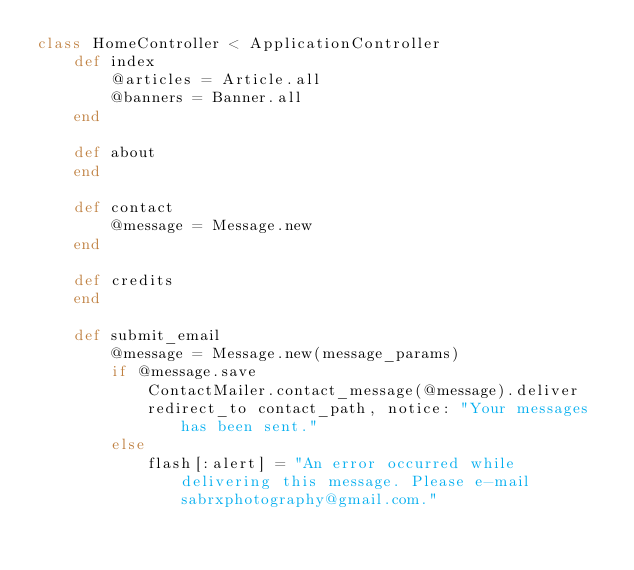Convert code to text. <code><loc_0><loc_0><loc_500><loc_500><_Ruby_>class HomeController < ApplicationController
	def index
		@articles = Article.all
		@banners = Banner.all
	end

	def about
	end

	def contact
		@message = Message.new
	end

	def credits
	end
	
	def submit_email
		@message = Message.new(message_params)
		if @message.save
			ContactMailer.contact_message(@message).deliver
			redirect_to contact_path, notice: "Your messages has been sent."
		else
			flash[:alert] = "An error occurred while delivering this message. Please e-mail sabrxphotography@gmail.com."</code> 